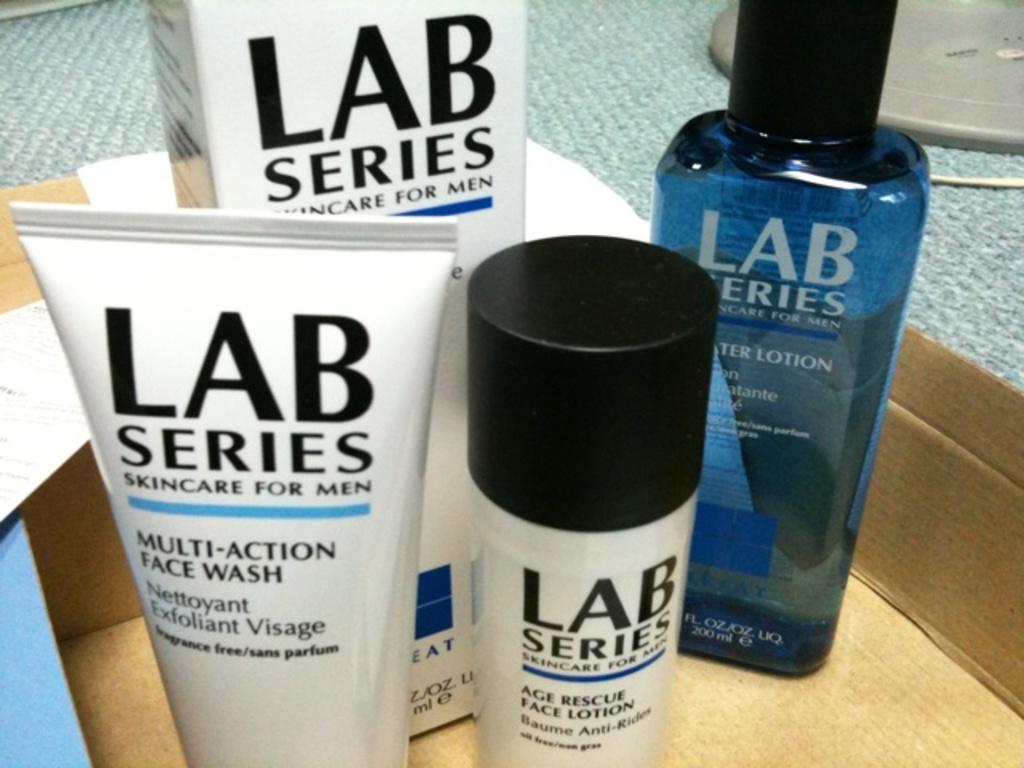Who is this skincare for?
Keep it short and to the point. Men. 